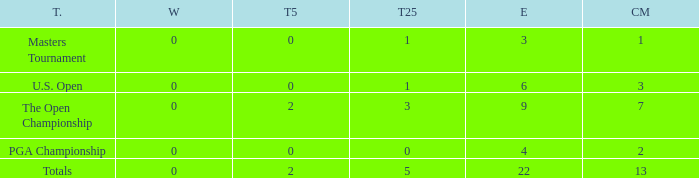What is the fewest number of top-25s for events with more than 13 cuts made? None. 